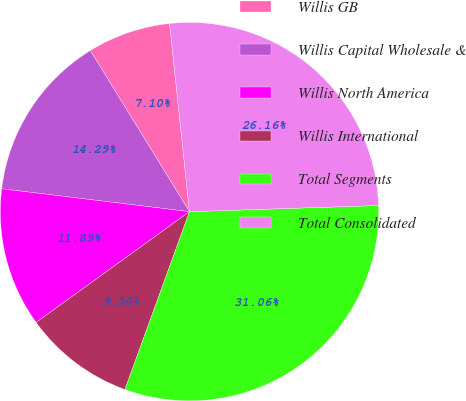Convert chart. <chart><loc_0><loc_0><loc_500><loc_500><pie_chart><fcel>Willis GB<fcel>Willis Capital Wholesale &<fcel>Willis North America<fcel>Willis International<fcel>Total Segments<fcel>Total Consolidated<nl><fcel>7.1%<fcel>14.29%<fcel>11.89%<fcel>9.5%<fcel>31.06%<fcel>26.16%<nl></chart> 